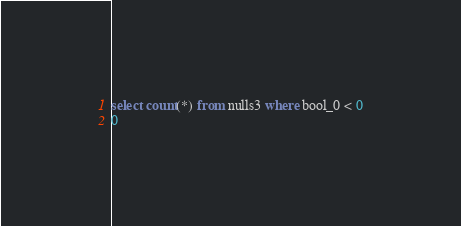<code> <loc_0><loc_0><loc_500><loc_500><_SQL_>select count(*) from nulls3 where bool_0 < 0
0
</code> 